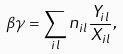Convert formula to latex. <formula><loc_0><loc_0><loc_500><loc_500>\beta \gamma = \sum _ { i l } n _ { i l } \frac { Y _ { i l } } { X _ { i l } } ,</formula> 